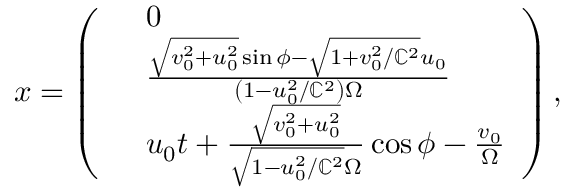Convert formula to latex. <formula><loc_0><loc_0><loc_500><loc_500>\begin{array} { r } { x = \left ( \begin{array} { r l } & { 0 } \\ & { \frac { \sqrt { v _ { 0 } ^ { 2 } + u _ { 0 } ^ { 2 } } \sin \phi - \sqrt { 1 + v _ { 0 } ^ { 2 } / \mathbb { C } ^ { 2 } } u _ { 0 } } { \left ( 1 - u _ { 0 } ^ { 2 } / \mathbb { C } ^ { 2 } \right ) \Omega } } \\ & { u _ { 0 } t + \frac { \sqrt { v _ { 0 } ^ { 2 } + u _ { 0 } ^ { 2 } } } { \sqrt { 1 - u _ { 0 } ^ { 2 } / \mathbb { C } ^ { 2 } } \Omega } \cos \phi - \frac { v _ { 0 } } { \Omega } } \end{array} \right ) , } \end{array}</formula> 